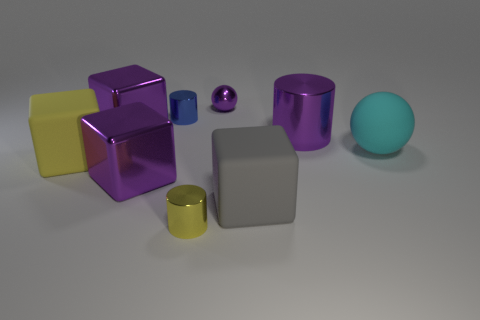Can you describe the objects in terms of their colors and sizes? Certainly! The image showcases objects in various sizes and colors: a large purple cube, a medium-sized yellow cube, a small gold cylinder, and a tiny purple sphere, all with glossy finishes. The matte objects include a large gray cube and a small teal sphere, enhancing the contrast in textures and finishes. 